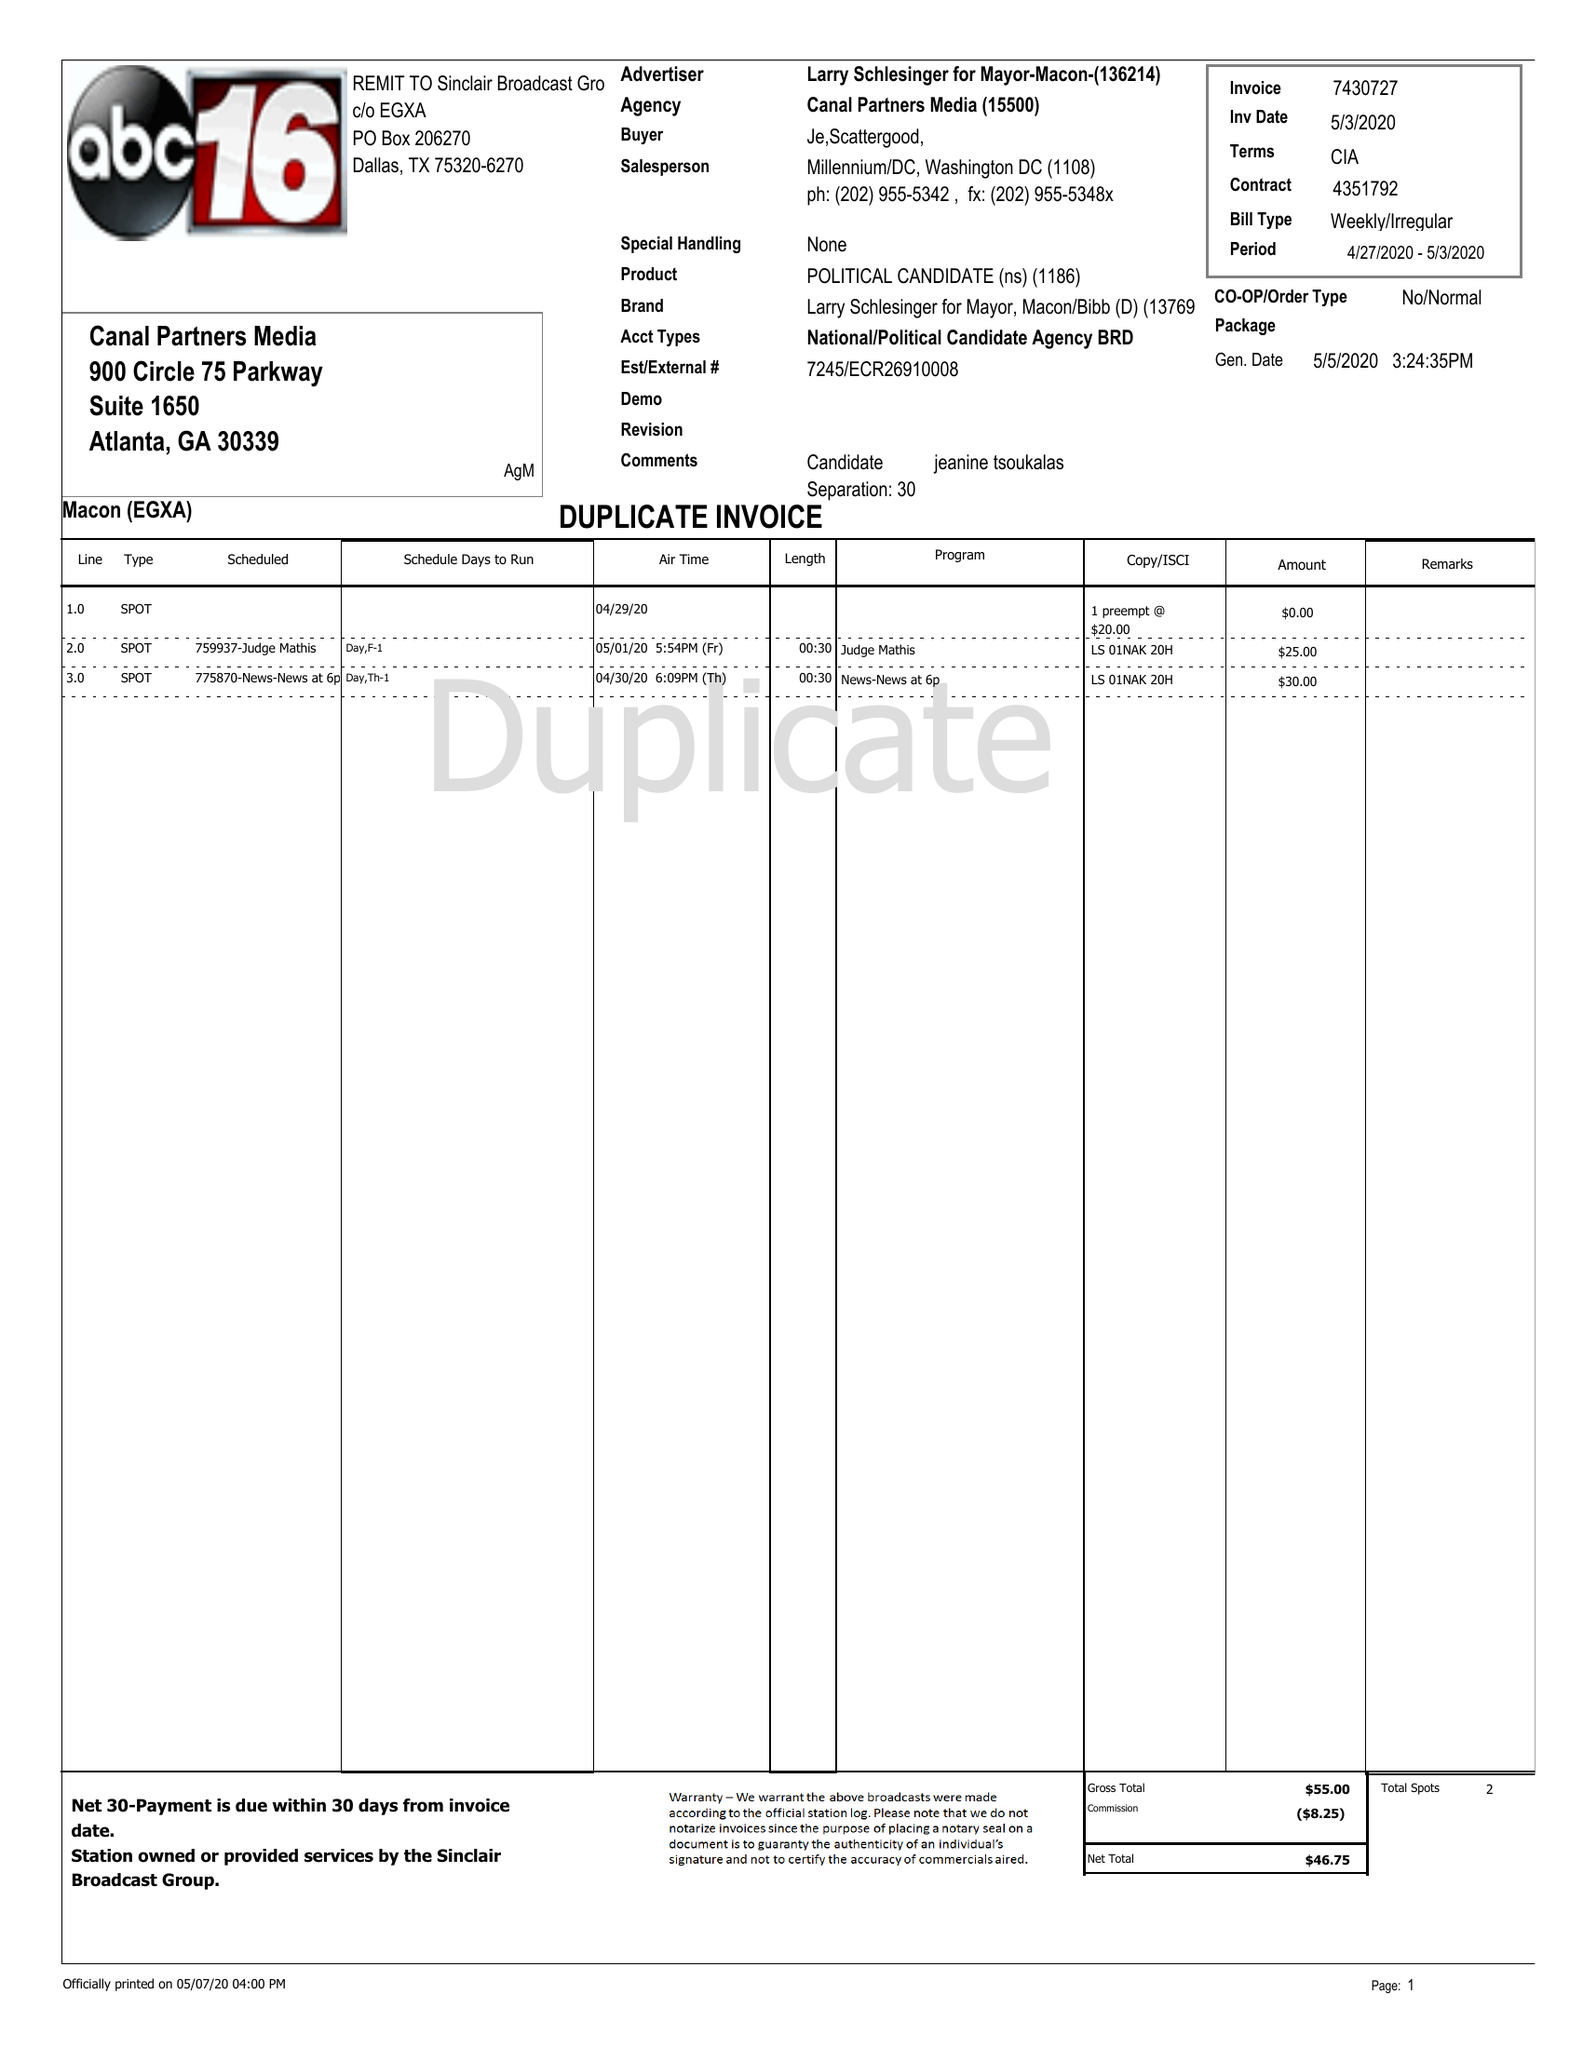What is the value for the flight_from?
Answer the question using a single word or phrase. 04/27/20 